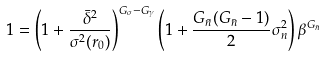Convert formula to latex. <formula><loc_0><loc_0><loc_500><loc_500>1 = \left ( 1 + \frac { \bar { \delta } ^ { 2 } } { \sigma ^ { 2 } ( r _ { 0 } ) } \right ) ^ { G _ { \sigma } - G _ { \gamma } } \left ( 1 + \frac { G _ { \bar { n } } ( G _ { \bar { n } } - 1 ) } { 2 } \sigma _ { n } ^ { 2 } \right ) \beta ^ { G _ { \bar { n } } }</formula> 